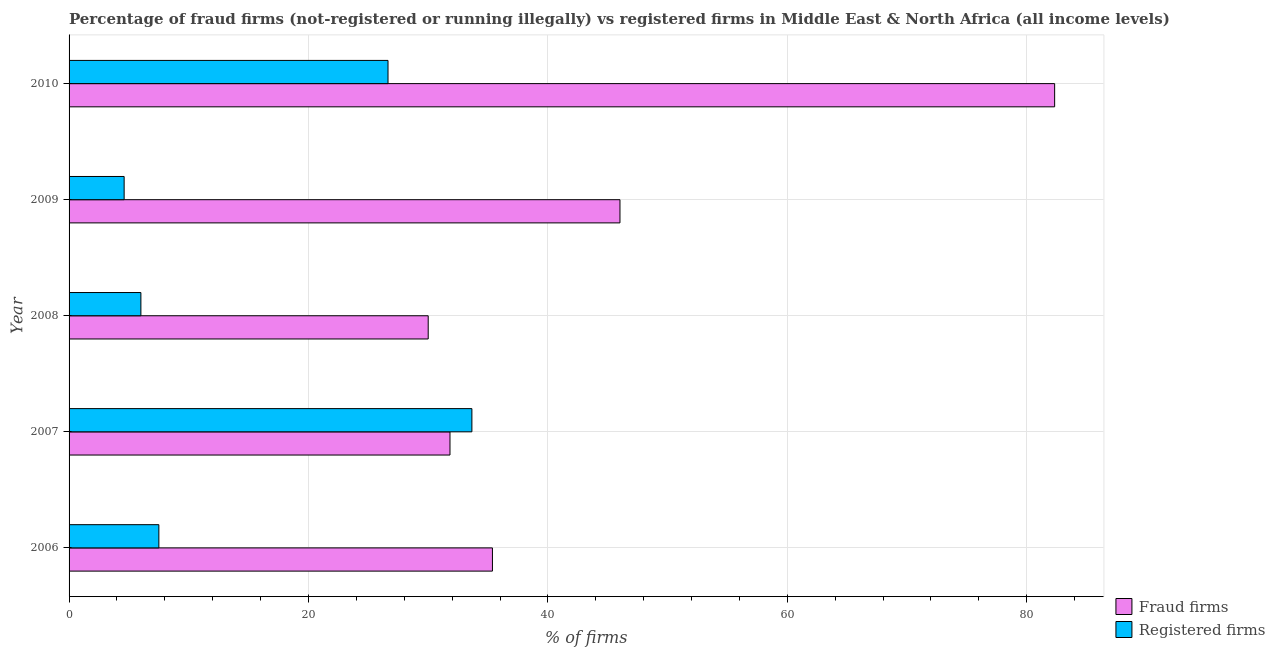How many groups of bars are there?
Ensure brevity in your answer.  5. What is the label of the 5th group of bars from the top?
Offer a terse response. 2006. In how many cases, is the number of bars for a given year not equal to the number of legend labels?
Provide a succinct answer. 0. What is the percentage of registered firms in 2009?
Your answer should be very brief. 4.6. Across all years, what is the maximum percentage of fraud firms?
Ensure brevity in your answer.  82.33. Across all years, what is the minimum percentage of fraud firms?
Give a very brief answer. 30. In which year was the percentage of fraud firms maximum?
Ensure brevity in your answer.  2010. In which year was the percentage of registered firms minimum?
Your answer should be compact. 2009. What is the total percentage of registered firms in the graph?
Ensure brevity in your answer.  78.39. What is the difference between the percentage of fraud firms in 2008 and that in 2010?
Offer a terse response. -52.33. What is the difference between the percentage of fraud firms in 2010 and the percentage of registered firms in 2006?
Give a very brief answer. 74.83. What is the average percentage of registered firms per year?
Give a very brief answer. 15.68. In the year 2006, what is the difference between the percentage of registered firms and percentage of fraud firms?
Your answer should be very brief. -27.87. In how many years, is the percentage of registered firms greater than 44 %?
Ensure brevity in your answer.  0. What is the ratio of the percentage of fraud firms in 2006 to that in 2009?
Offer a very short reply. 0.77. Is the percentage of fraud firms in 2008 less than that in 2010?
Ensure brevity in your answer.  Yes. What is the difference between the highest and the second highest percentage of registered firms?
Provide a short and direct response. 7.01. What is the difference between the highest and the lowest percentage of fraud firms?
Offer a terse response. 52.33. What does the 1st bar from the top in 2007 represents?
Your response must be concise. Registered firms. What does the 2nd bar from the bottom in 2010 represents?
Give a very brief answer. Registered firms. How many years are there in the graph?
Offer a terse response. 5. Does the graph contain grids?
Give a very brief answer. Yes. Where does the legend appear in the graph?
Ensure brevity in your answer.  Bottom right. How are the legend labels stacked?
Your answer should be compact. Vertical. What is the title of the graph?
Keep it short and to the point. Percentage of fraud firms (not-registered or running illegally) vs registered firms in Middle East & North Africa (all income levels). Does "Methane emissions" appear as one of the legend labels in the graph?
Keep it short and to the point. No. What is the label or title of the X-axis?
Your answer should be very brief. % of firms. What is the % of firms of Fraud firms in 2006?
Your answer should be very brief. 35.37. What is the % of firms of Fraud firms in 2007?
Your response must be concise. 31.82. What is the % of firms in Registered firms in 2007?
Your answer should be compact. 33.65. What is the % of firms of Fraud firms in 2008?
Provide a short and direct response. 30. What is the % of firms in Registered firms in 2008?
Provide a succinct answer. 6. What is the % of firms of Fraud firms in 2009?
Give a very brief answer. 46.02. What is the % of firms of Registered firms in 2009?
Make the answer very short. 4.6. What is the % of firms in Fraud firms in 2010?
Offer a terse response. 82.33. What is the % of firms of Registered firms in 2010?
Keep it short and to the point. 26.64. Across all years, what is the maximum % of firms of Fraud firms?
Ensure brevity in your answer.  82.33. Across all years, what is the maximum % of firms in Registered firms?
Ensure brevity in your answer.  33.65. What is the total % of firms of Fraud firms in the graph?
Offer a very short reply. 225.54. What is the total % of firms in Registered firms in the graph?
Make the answer very short. 78.39. What is the difference between the % of firms in Fraud firms in 2006 and that in 2007?
Your answer should be very brief. 3.55. What is the difference between the % of firms in Registered firms in 2006 and that in 2007?
Ensure brevity in your answer.  -26.15. What is the difference between the % of firms of Fraud firms in 2006 and that in 2008?
Ensure brevity in your answer.  5.37. What is the difference between the % of firms of Fraud firms in 2006 and that in 2009?
Make the answer very short. -10.65. What is the difference between the % of firms of Registered firms in 2006 and that in 2009?
Ensure brevity in your answer.  2.9. What is the difference between the % of firms in Fraud firms in 2006 and that in 2010?
Make the answer very short. -46.96. What is the difference between the % of firms in Registered firms in 2006 and that in 2010?
Give a very brief answer. -19.14. What is the difference between the % of firms of Fraud firms in 2007 and that in 2008?
Your answer should be very brief. 1.82. What is the difference between the % of firms in Registered firms in 2007 and that in 2008?
Make the answer very short. 27.65. What is the difference between the % of firms of Registered firms in 2007 and that in 2009?
Your response must be concise. 29.05. What is the difference between the % of firms in Fraud firms in 2007 and that in 2010?
Make the answer very short. -50.51. What is the difference between the % of firms in Registered firms in 2007 and that in 2010?
Offer a very short reply. 7.01. What is the difference between the % of firms in Fraud firms in 2008 and that in 2009?
Give a very brief answer. -16.02. What is the difference between the % of firms in Registered firms in 2008 and that in 2009?
Ensure brevity in your answer.  1.4. What is the difference between the % of firms of Fraud firms in 2008 and that in 2010?
Provide a short and direct response. -52.33. What is the difference between the % of firms in Registered firms in 2008 and that in 2010?
Ensure brevity in your answer.  -20.64. What is the difference between the % of firms of Fraud firms in 2009 and that in 2010?
Provide a short and direct response. -36.31. What is the difference between the % of firms of Registered firms in 2009 and that in 2010?
Offer a very short reply. -22.04. What is the difference between the % of firms of Fraud firms in 2006 and the % of firms of Registered firms in 2007?
Provide a short and direct response. 1.72. What is the difference between the % of firms in Fraud firms in 2006 and the % of firms in Registered firms in 2008?
Give a very brief answer. 29.37. What is the difference between the % of firms in Fraud firms in 2006 and the % of firms in Registered firms in 2009?
Your answer should be compact. 30.77. What is the difference between the % of firms of Fraud firms in 2006 and the % of firms of Registered firms in 2010?
Your answer should be very brief. 8.72. What is the difference between the % of firms in Fraud firms in 2007 and the % of firms in Registered firms in 2008?
Provide a short and direct response. 25.82. What is the difference between the % of firms of Fraud firms in 2007 and the % of firms of Registered firms in 2009?
Offer a terse response. 27.22. What is the difference between the % of firms of Fraud firms in 2007 and the % of firms of Registered firms in 2010?
Provide a short and direct response. 5.18. What is the difference between the % of firms of Fraud firms in 2008 and the % of firms of Registered firms in 2009?
Your response must be concise. 25.4. What is the difference between the % of firms in Fraud firms in 2008 and the % of firms in Registered firms in 2010?
Provide a short and direct response. 3.36. What is the difference between the % of firms of Fraud firms in 2009 and the % of firms of Registered firms in 2010?
Your answer should be compact. 19.38. What is the average % of firms in Fraud firms per year?
Your answer should be compact. 45.11. What is the average % of firms in Registered firms per year?
Your response must be concise. 15.68. In the year 2006, what is the difference between the % of firms of Fraud firms and % of firms of Registered firms?
Make the answer very short. 27.87. In the year 2007, what is the difference between the % of firms in Fraud firms and % of firms in Registered firms?
Keep it short and to the point. -1.83. In the year 2008, what is the difference between the % of firms in Fraud firms and % of firms in Registered firms?
Ensure brevity in your answer.  24. In the year 2009, what is the difference between the % of firms of Fraud firms and % of firms of Registered firms?
Offer a terse response. 41.42. In the year 2010, what is the difference between the % of firms in Fraud firms and % of firms in Registered firms?
Keep it short and to the point. 55.69. What is the ratio of the % of firms of Fraud firms in 2006 to that in 2007?
Your answer should be very brief. 1.11. What is the ratio of the % of firms in Registered firms in 2006 to that in 2007?
Your response must be concise. 0.22. What is the ratio of the % of firms of Fraud firms in 2006 to that in 2008?
Your response must be concise. 1.18. What is the ratio of the % of firms in Registered firms in 2006 to that in 2008?
Give a very brief answer. 1.25. What is the ratio of the % of firms in Fraud firms in 2006 to that in 2009?
Provide a short and direct response. 0.77. What is the ratio of the % of firms of Registered firms in 2006 to that in 2009?
Give a very brief answer. 1.63. What is the ratio of the % of firms in Fraud firms in 2006 to that in 2010?
Make the answer very short. 0.43. What is the ratio of the % of firms in Registered firms in 2006 to that in 2010?
Your answer should be compact. 0.28. What is the ratio of the % of firms of Fraud firms in 2007 to that in 2008?
Ensure brevity in your answer.  1.06. What is the ratio of the % of firms of Registered firms in 2007 to that in 2008?
Your response must be concise. 5.61. What is the ratio of the % of firms of Fraud firms in 2007 to that in 2009?
Make the answer very short. 0.69. What is the ratio of the % of firms of Registered firms in 2007 to that in 2009?
Your response must be concise. 7.32. What is the ratio of the % of firms in Fraud firms in 2007 to that in 2010?
Your response must be concise. 0.39. What is the ratio of the % of firms of Registered firms in 2007 to that in 2010?
Provide a short and direct response. 1.26. What is the ratio of the % of firms in Fraud firms in 2008 to that in 2009?
Your response must be concise. 0.65. What is the ratio of the % of firms of Registered firms in 2008 to that in 2009?
Keep it short and to the point. 1.3. What is the ratio of the % of firms of Fraud firms in 2008 to that in 2010?
Your answer should be compact. 0.36. What is the ratio of the % of firms of Registered firms in 2008 to that in 2010?
Keep it short and to the point. 0.23. What is the ratio of the % of firms in Fraud firms in 2009 to that in 2010?
Offer a very short reply. 0.56. What is the ratio of the % of firms in Registered firms in 2009 to that in 2010?
Make the answer very short. 0.17. What is the difference between the highest and the second highest % of firms in Fraud firms?
Your response must be concise. 36.31. What is the difference between the highest and the second highest % of firms of Registered firms?
Offer a terse response. 7.01. What is the difference between the highest and the lowest % of firms of Fraud firms?
Your answer should be compact. 52.33. What is the difference between the highest and the lowest % of firms of Registered firms?
Give a very brief answer. 29.05. 